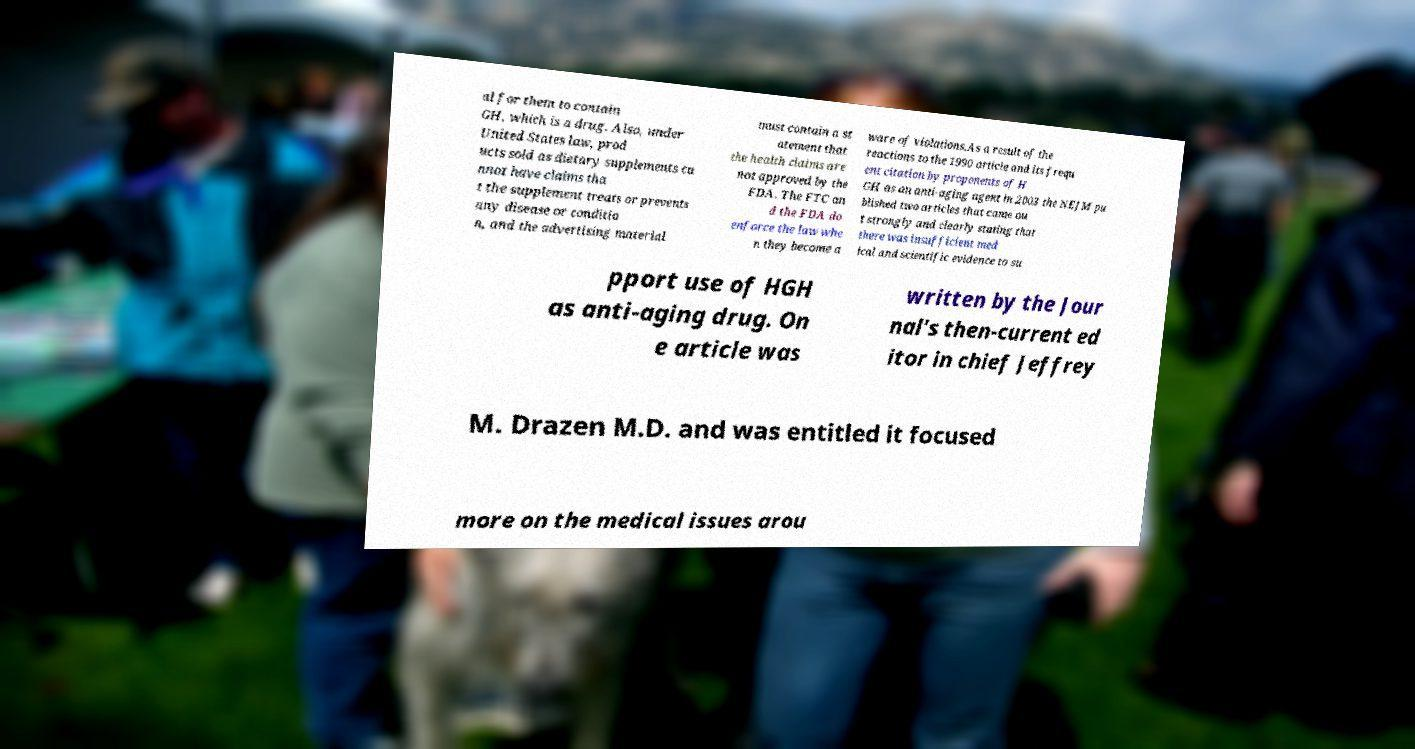For documentation purposes, I need the text within this image transcribed. Could you provide that? al for them to contain GH, which is a drug. Also, under United States law, prod ucts sold as dietary supplements ca nnot have claims tha t the supplement treats or prevents any disease or conditio n, and the advertising material must contain a st atement that the health claims are not approved by the FDA. The FTC an d the FDA do enforce the law whe n they become a ware of violations.As a result of the reactions to the 1990 article and its frequ ent citation by proponents of H GH as an anti-aging agent in 2003 the NEJM pu blished two articles that came ou t strongly and clearly stating that there was insufficient med ical and scientific evidence to su pport use of HGH as anti-aging drug. On e article was written by the Jour nal's then-current ed itor in chief Jeffrey M. Drazen M.D. and was entitled it focused more on the medical issues arou 